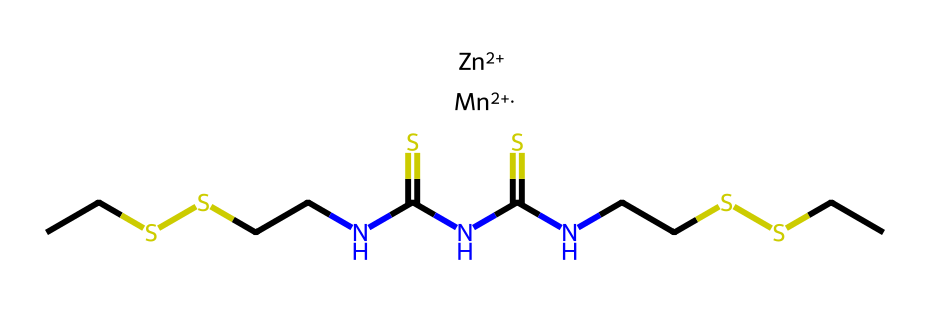What is the molecular formula of mancozeb? The SMILES representation shows the specific atoms present in the structure. By counting all the elements, we can derive the molecular formula, which includes carbon (C), hydrogen (H), nitrogen (N), sulfur (S), manganese (Mn), and zinc (Zn). The overall formula is C6H10N4S4ZnMn.
Answer: C6H10N4S4ZnMn How many nitrogen atoms are in the structure? From the SMILES representation, we can identify nitrogen (N) symbols. Counting these gives us four nitrogen atoms in the molecular structure.
Answer: 4 What are the metal elements present in mancozeb? The SMILES indicates the presence of two metal elements represented by their symbols: zinc (Zn) and manganese (Mn). Thus, the metal components are identified directly from their symbols in the structure.
Answer: zinc, manganese Which functional groups are present in this compound? The structure contains thiourea functional groups as indicated by the NC(=S)NC(=S) portions in the SMILES. These groups are characteristic of thioureas, which suggest fungicidal properties.
Answer: thiourea How does the molecular structure suggest mancozeb's function as a fungicide? The presence of sulfur atoms (S) and nitrogen atoms (N) along with the specific arrangement indicates typical characteristics of fungicides. Sulfur often plays a role in antifungal activity and the thiourea structure contributes to its efficacy.
Answer: sulfur, nitrogen What type of isomerism could this compound exhibit? The presence of the multiple functional groups in the structure combined with the connectivity of atoms allows for geometrical isomerism, especially in relation to the configuration around the sulfur atoms.
Answer: geometrical isomerism 